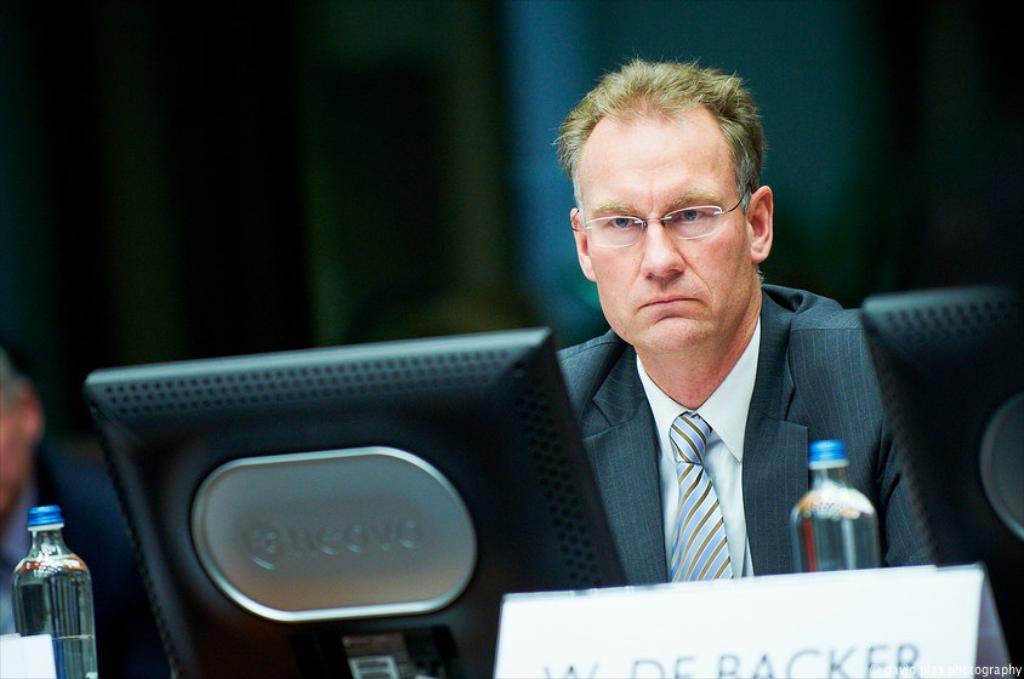Could you give a brief overview of what you see in this image? A man is sitting on the chair and looking into a monitor. It's a bottle and he wear coat,tie and spectacles. 